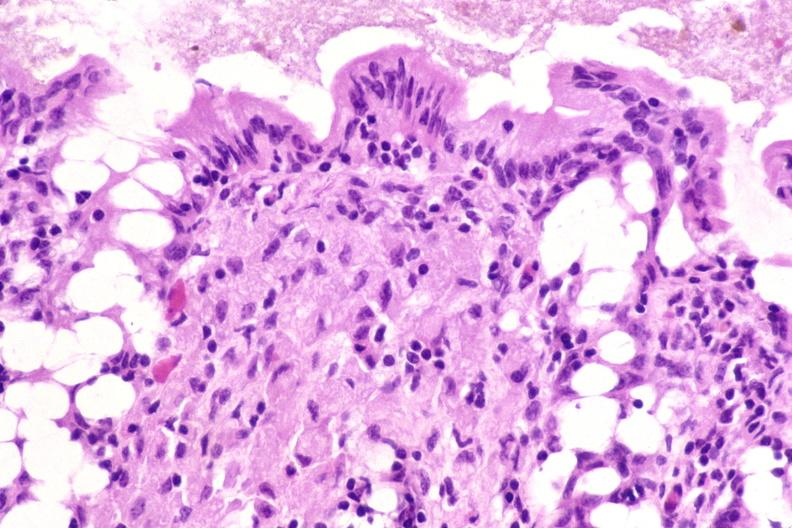where is this from?
Answer the question using a single word or phrase. Gastrointestinal system 